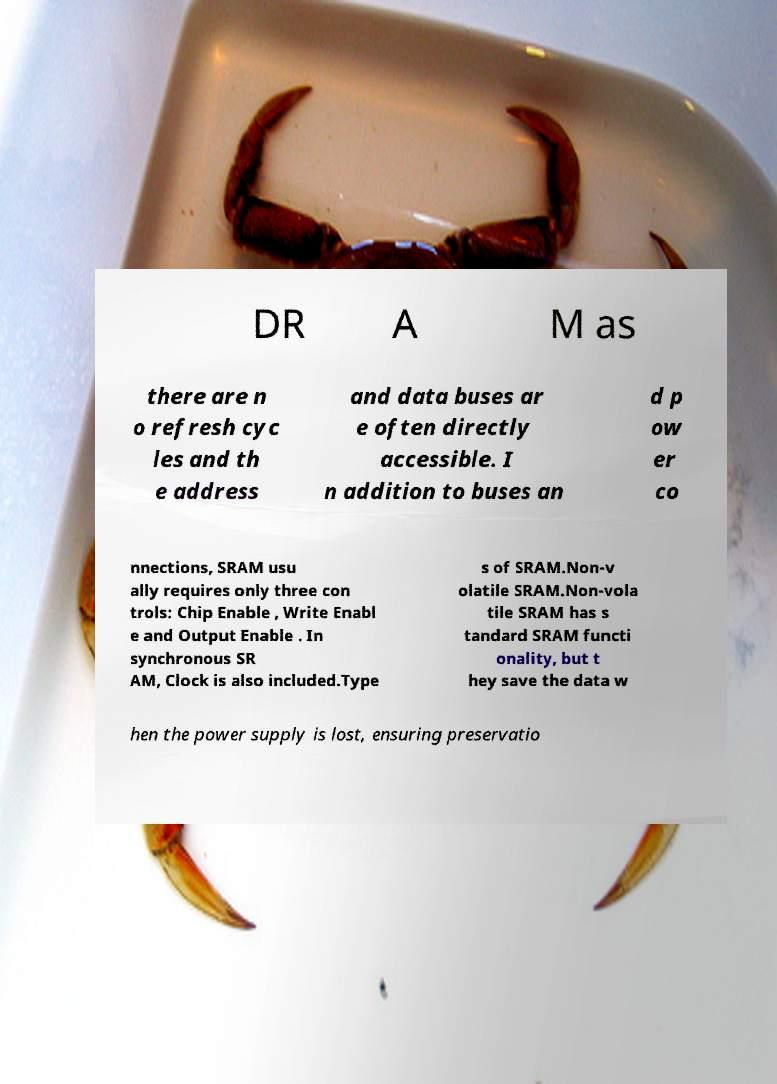What messages or text are displayed in this image? I need them in a readable, typed format. DR A M as there are n o refresh cyc les and th e address and data buses ar e often directly accessible. I n addition to buses an d p ow er co nnections, SRAM usu ally requires only three con trols: Chip Enable , Write Enabl e and Output Enable . In synchronous SR AM, Clock is also included.Type s of SRAM.Non-v olatile SRAM.Non-vola tile SRAM has s tandard SRAM functi onality, but t hey save the data w hen the power supply is lost, ensuring preservatio 